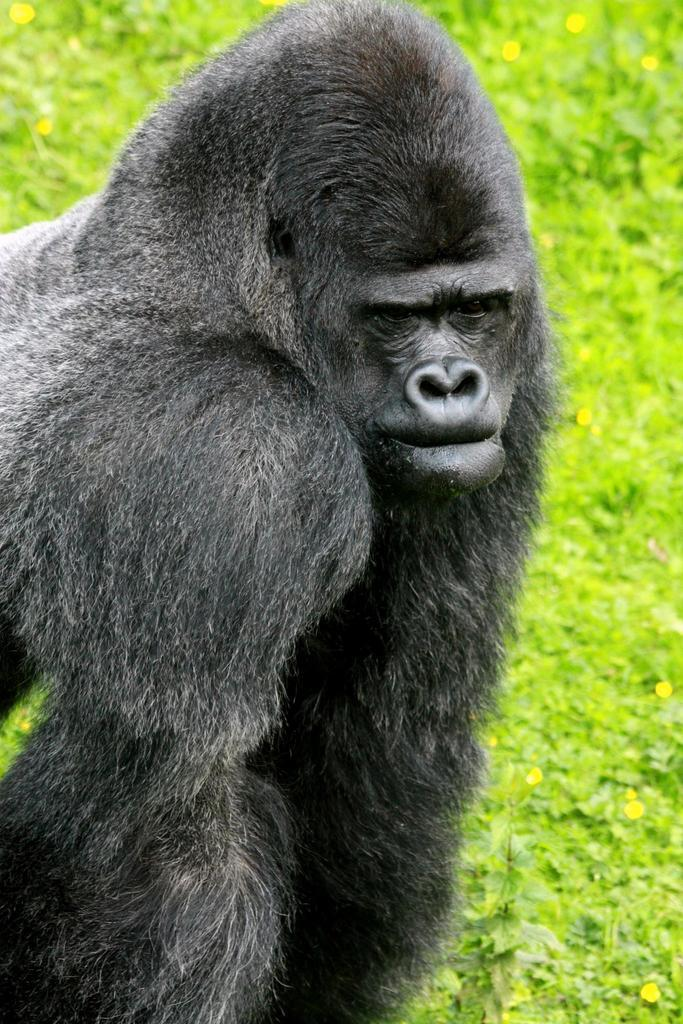Where was the image taken? The image was taken outdoors. What can be seen in the background of the image? There are plants in the background of the image. What animal is on the left side of the image? There is a chimpanzee on the left side of the image. Reasoning: Let's think step by following the guidelines to produce the conversation. We start by identifying the location of the image, which is outdoors. Then, we describe the background, which includes plants. Finally, we focus on the main subject of the image, which is the chimpanzee. Each question is designed to elicit a specific detail about the image that is known from the provided facts. Absurd Question/Answer: What is the weight of the yak in the image? There is no yak present in the image, so it is not possible to determine its weight. 